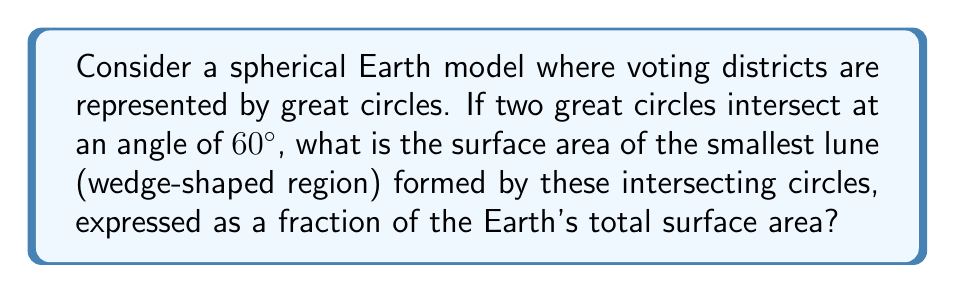Show me your answer to this math problem. To solve this problem, we'll follow these steps:

1) Recall that the surface area of a lune is proportional to the angle between the great circles that form it. The formula for the area of a lune is:

   $A_{lune} = \frac{\theta}{2\pi} \cdot 4\pi r^2$

   where $\theta$ is the angle between the great circles in radians, and $r$ is the radius of the sphere.

2) Convert the given angle from degrees to radians:
   
   $60^\circ = \frac{60 \cdot \pi}{180} = \frac{\pi}{3}$ radians

3) Substitute this into our formula:

   $A_{lune} = \frac{\frac{\pi}{3}}{2\pi} \cdot 4\pi r^2$

4) Simplify:

   $A_{lune} = \frac{1}{6} \cdot 4\pi r^2 = \frac{2\pi r^2}{3}$

5) The total surface area of a sphere is $4\pi r^2$. To express the lune's area as a fraction of the Earth's surface area, we divide:

   $\frac{A_{lune}}{A_{sphere}} = \frac{\frac{2\pi r^2}{3}}{4\pi r^2} = \frac{1}{6}$

Thus, the smallest lune formed by the intersecting great circles occupies $\frac{1}{6}$ of the Earth's surface area.
Answer: $\frac{1}{6}$ 